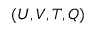Convert formula to latex. <formula><loc_0><loc_0><loc_500><loc_500>( U , V , T , Q )</formula> 